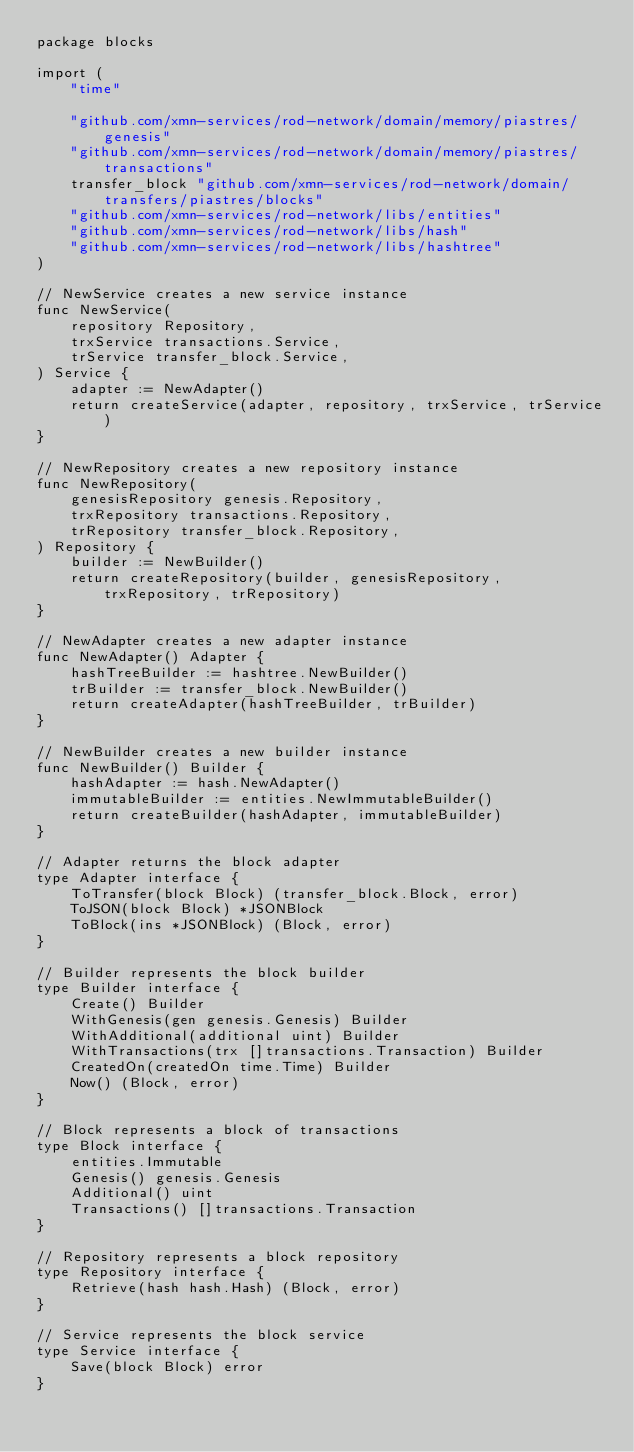Convert code to text. <code><loc_0><loc_0><loc_500><loc_500><_Go_>package blocks

import (
	"time"

	"github.com/xmn-services/rod-network/domain/memory/piastres/genesis"
	"github.com/xmn-services/rod-network/domain/memory/piastres/transactions"
	transfer_block "github.com/xmn-services/rod-network/domain/transfers/piastres/blocks"
	"github.com/xmn-services/rod-network/libs/entities"
	"github.com/xmn-services/rod-network/libs/hash"
	"github.com/xmn-services/rod-network/libs/hashtree"
)

// NewService creates a new service instance
func NewService(
	repository Repository,
	trxService transactions.Service,
	trService transfer_block.Service,
) Service {
	adapter := NewAdapter()
	return createService(adapter, repository, trxService, trService)
}

// NewRepository creates a new repository instance
func NewRepository(
	genesisRepository genesis.Repository,
	trxRepository transactions.Repository,
	trRepository transfer_block.Repository,
) Repository {
	builder := NewBuilder()
	return createRepository(builder, genesisRepository, trxRepository, trRepository)
}

// NewAdapter creates a new adapter instance
func NewAdapter() Adapter {
	hashTreeBuilder := hashtree.NewBuilder()
	trBuilder := transfer_block.NewBuilder()
	return createAdapter(hashTreeBuilder, trBuilder)
}

// NewBuilder creates a new builder instance
func NewBuilder() Builder {
	hashAdapter := hash.NewAdapter()
	immutableBuilder := entities.NewImmutableBuilder()
	return createBuilder(hashAdapter, immutableBuilder)
}

// Adapter returns the block adapter
type Adapter interface {
	ToTransfer(block Block) (transfer_block.Block, error)
	ToJSON(block Block) *JSONBlock
	ToBlock(ins *JSONBlock) (Block, error)
}

// Builder represents the block builder
type Builder interface {
	Create() Builder
	WithGenesis(gen genesis.Genesis) Builder
	WithAdditional(additional uint) Builder
	WithTransactions(trx []transactions.Transaction) Builder
	CreatedOn(createdOn time.Time) Builder
	Now() (Block, error)
}

// Block represents a block of transactions
type Block interface {
	entities.Immutable
	Genesis() genesis.Genesis
	Additional() uint
	Transactions() []transactions.Transaction
}

// Repository represents a block repository
type Repository interface {
	Retrieve(hash hash.Hash) (Block, error)
}

// Service represents the block service
type Service interface {
	Save(block Block) error
}
</code> 